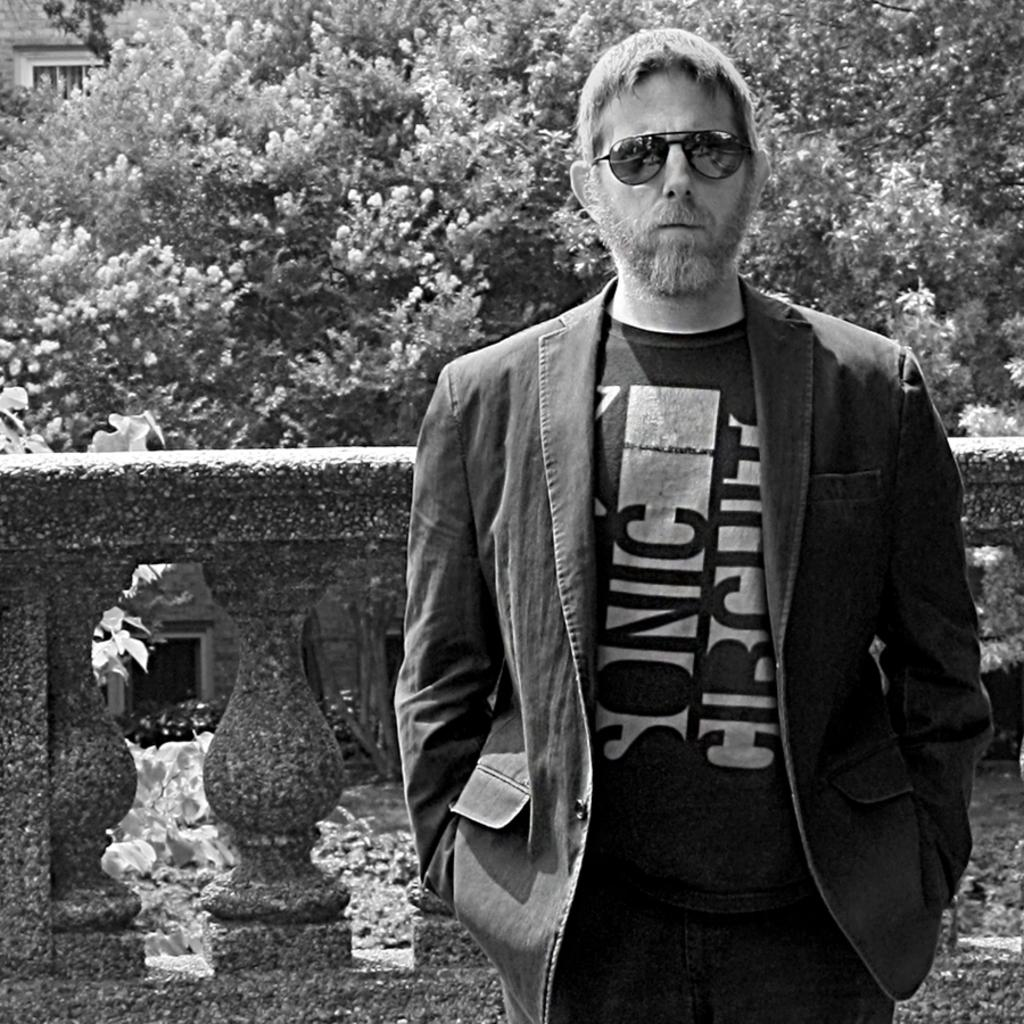What is the main subject of the image? There is a man standing in the image. Can you describe the man's appearance? The man is wearing glasses. What can be seen in the background of the image? There is a fence and trees in the background of the image. How many rabbits are hopping around the man in the image? There are no rabbits present in the image. What type of division is being performed by the man in the image? There is no division being performed by the man in the image. 